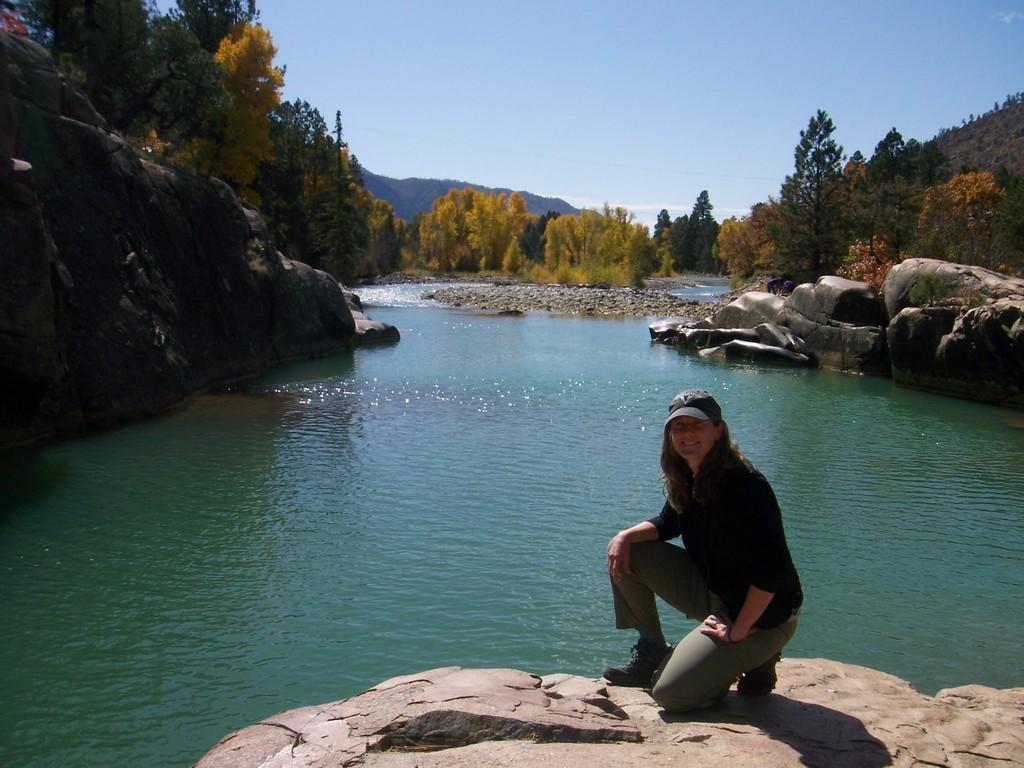Describe this image in one or two sentences. In this image we can see a lady. There is a lake in the image. There are many trees and plants in the image. There is a sky in the image. There are many rocks in the image. There are few hills in the image. 